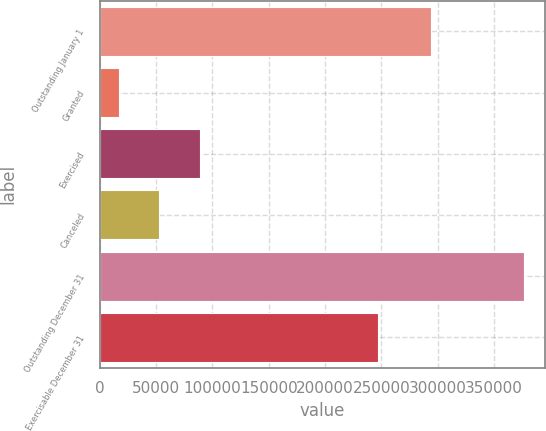<chart> <loc_0><loc_0><loc_500><loc_500><bar_chart><fcel>Outstanding January 1<fcel>Granted<fcel>Exercised<fcel>Canceled<fcel>Outstanding December 31<fcel>Exercisable December 31<nl><fcel>294026<fcel>16667<fcel>88599.6<fcel>52633.3<fcel>376330<fcel>246945<nl></chart> 